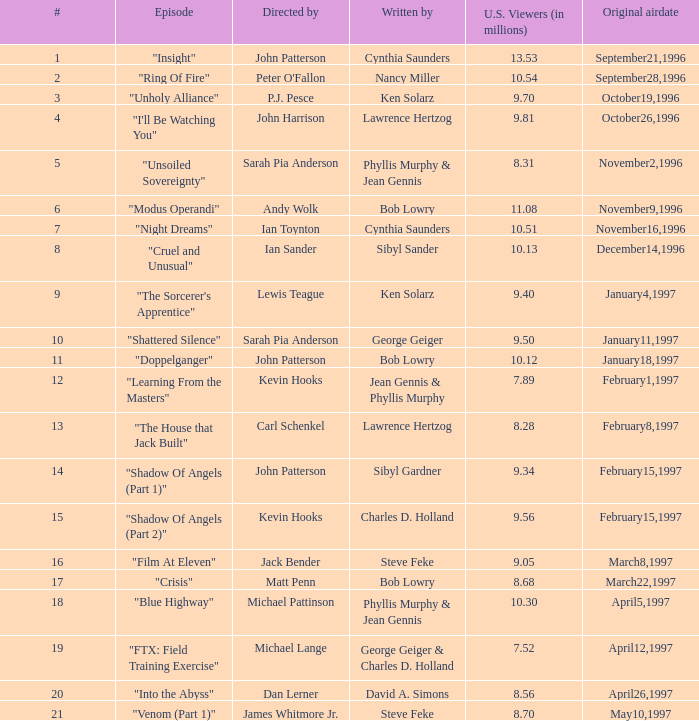Who wrote the episode with 9.81 million US viewers? Lawrence Hertzog. 